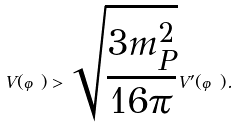Convert formula to latex. <formula><loc_0><loc_0><loc_500><loc_500>V ( \varphi ) > \sqrt { \frac { 3 m _ { P } ^ { 2 } } { 1 6 \pi } } V ^ { \prime } ( \varphi ) .</formula> 